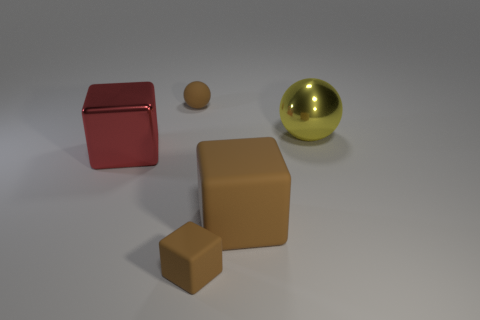Add 2 big yellow spheres. How many objects exist? 7 Subtract all spheres. How many objects are left? 3 Add 2 green blocks. How many green blocks exist? 2 Subtract 0 blue spheres. How many objects are left? 5 Subtract all big cyan matte objects. Subtract all small spheres. How many objects are left? 4 Add 3 big brown objects. How many big brown objects are left? 4 